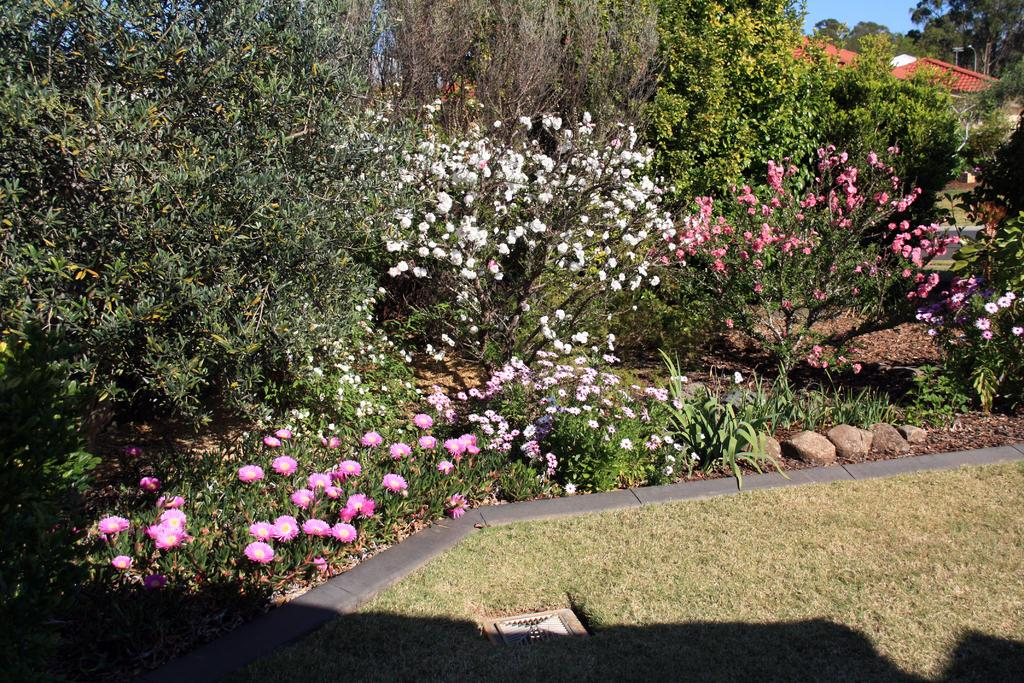What type of vegetation can be seen in the image? There are trees in the image. What type of structures are visible in the image? There are houses in the image. What type of ground cover is present in the image? Small stones are present in the image. What colors of flowers can be seen in the image? There are flowers in pink, white, and peach colors in the image. What color is the sky in the image? The sky is blue in the image. Can you see any tanks in the image? There are no tanks present in the image. What type of grass is growing in the image? There is no grass visible in the image; it features trees, houses, small stones, and flowers. 